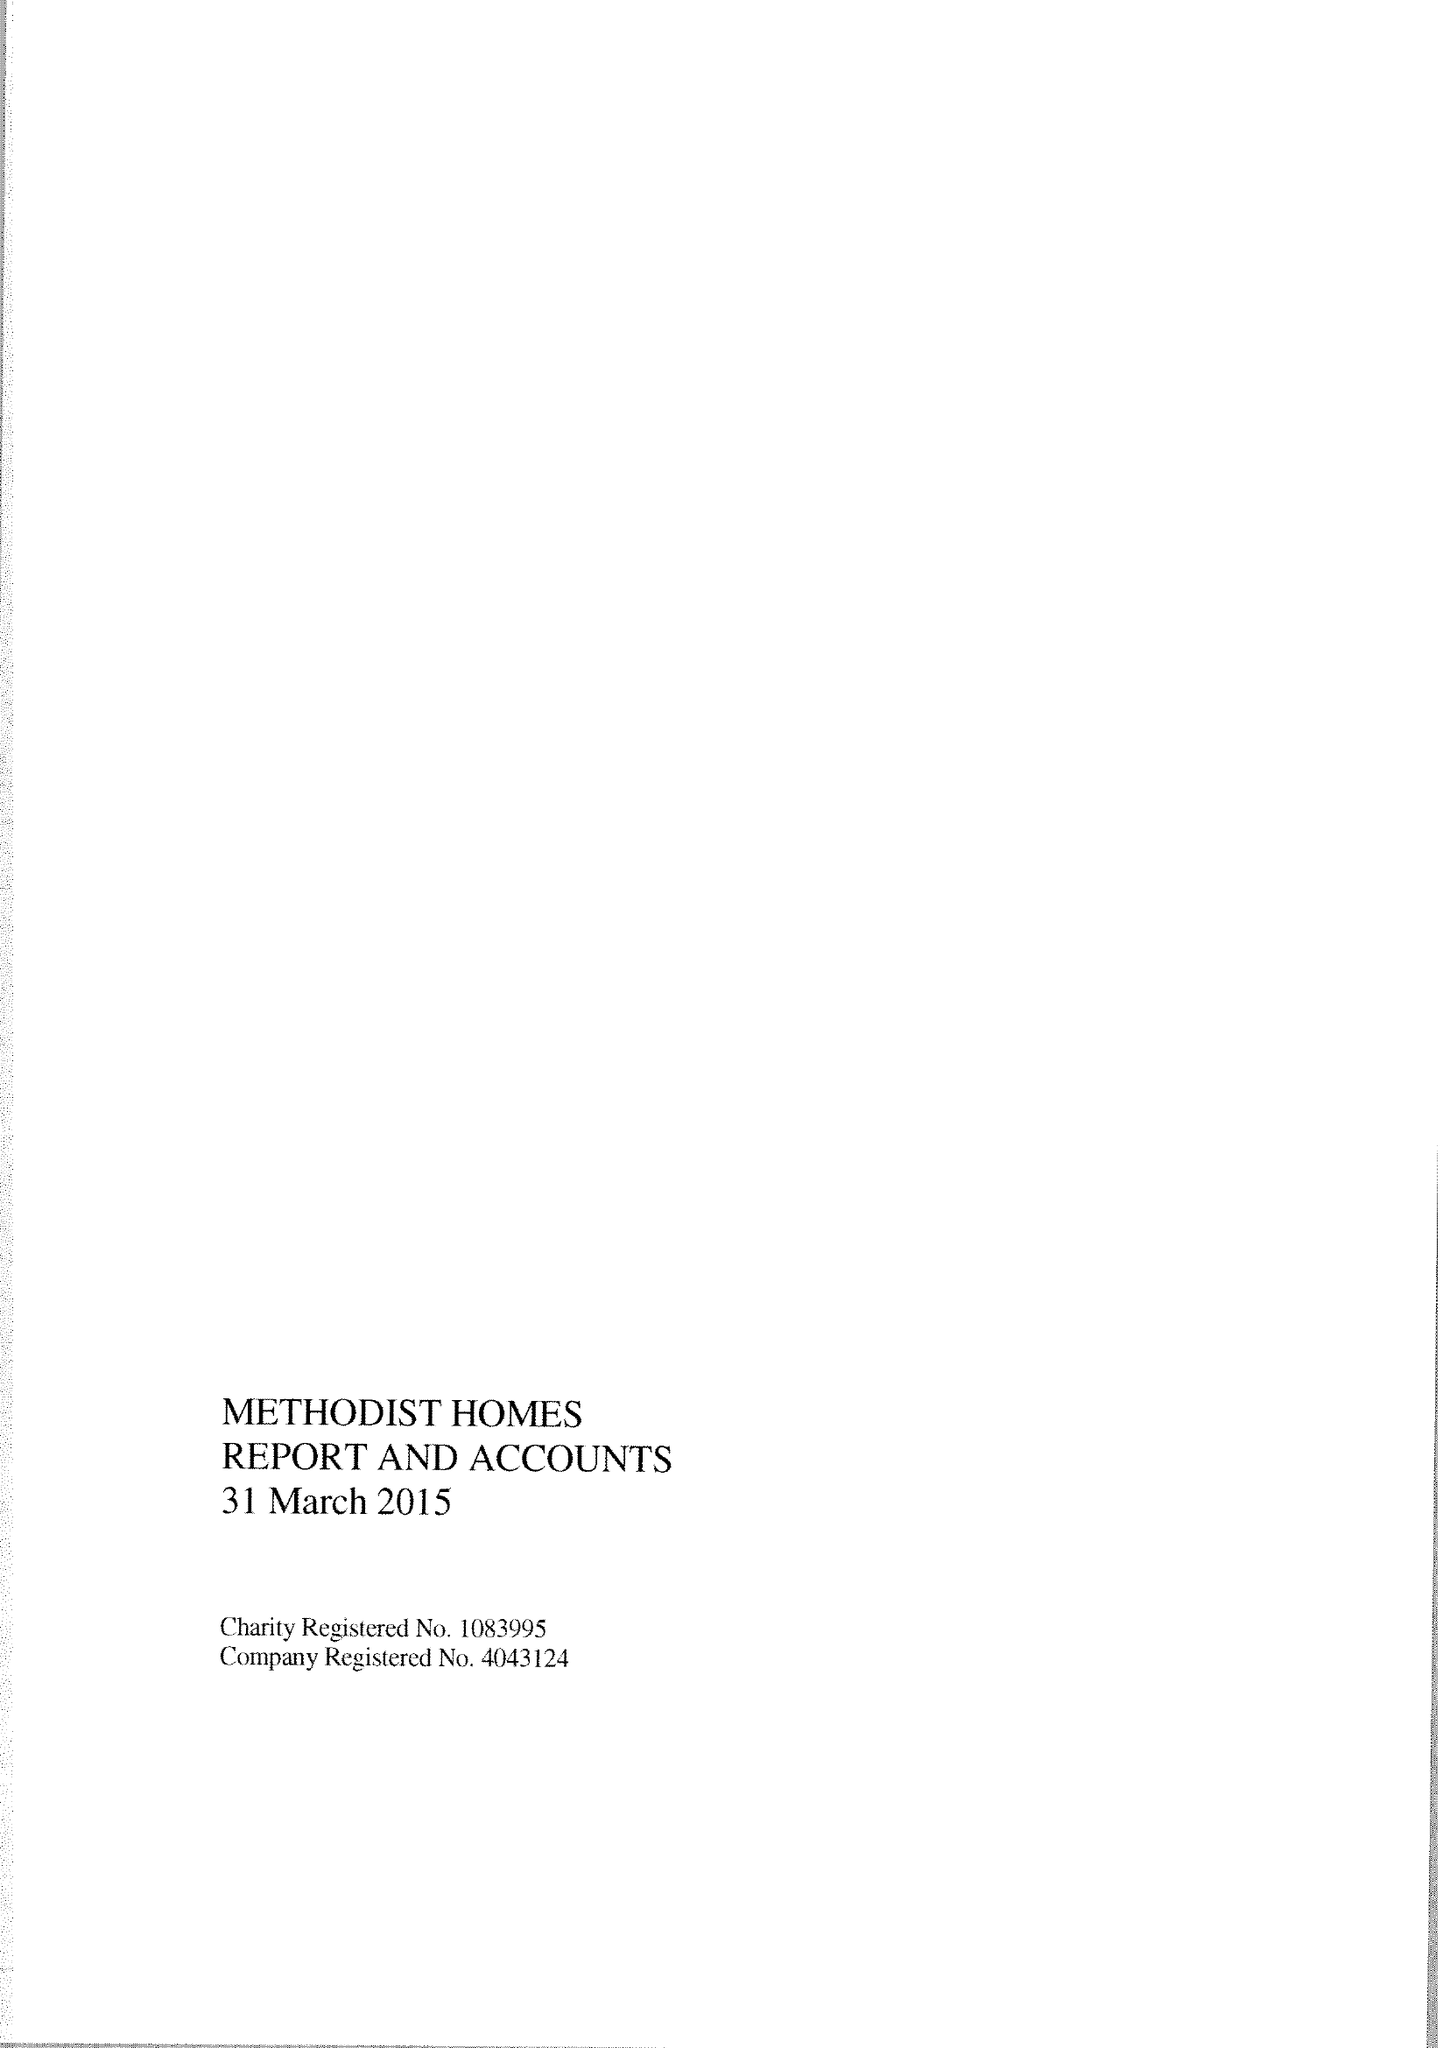What is the value for the spending_annually_in_british_pounds?
Answer the question using a single word or phrase. 174171000.00 